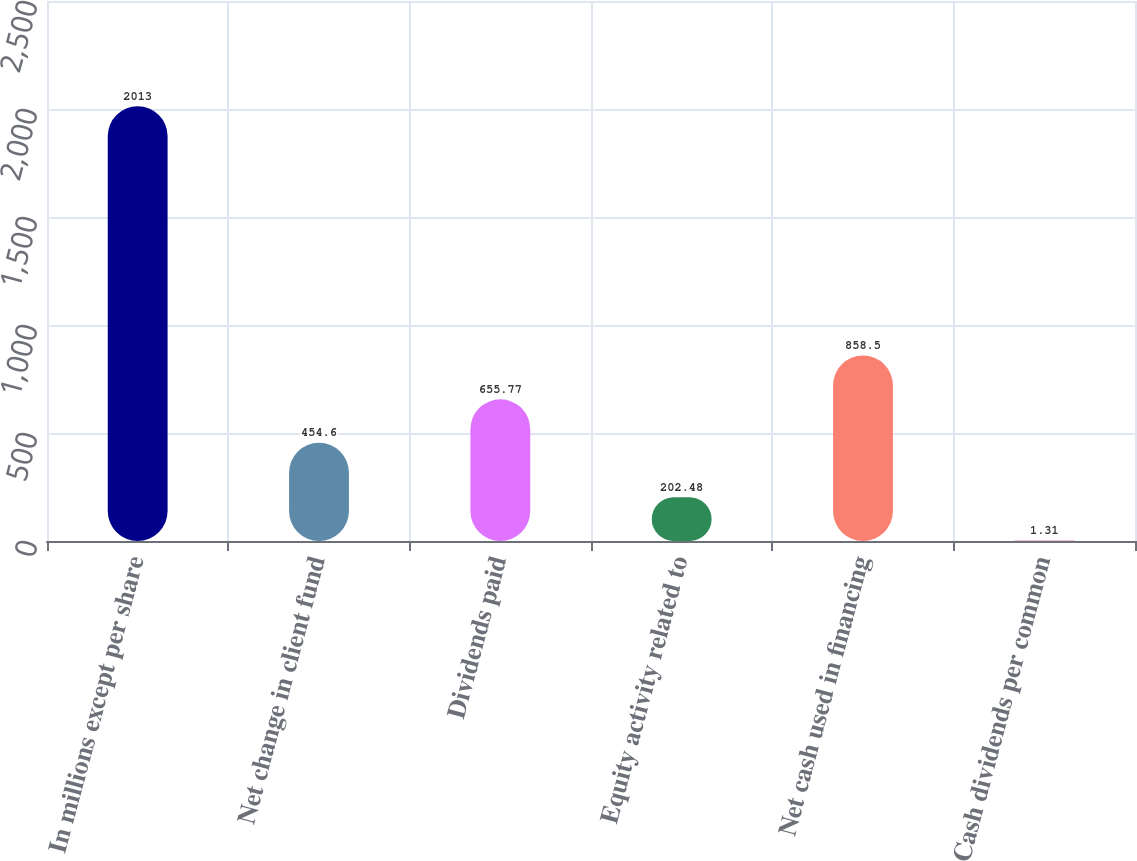<chart> <loc_0><loc_0><loc_500><loc_500><bar_chart><fcel>In millions except per share<fcel>Net change in client fund<fcel>Dividends paid<fcel>Equity activity related to<fcel>Net cash used in financing<fcel>Cash dividends per common<nl><fcel>2013<fcel>454.6<fcel>655.77<fcel>202.48<fcel>858.5<fcel>1.31<nl></chart> 